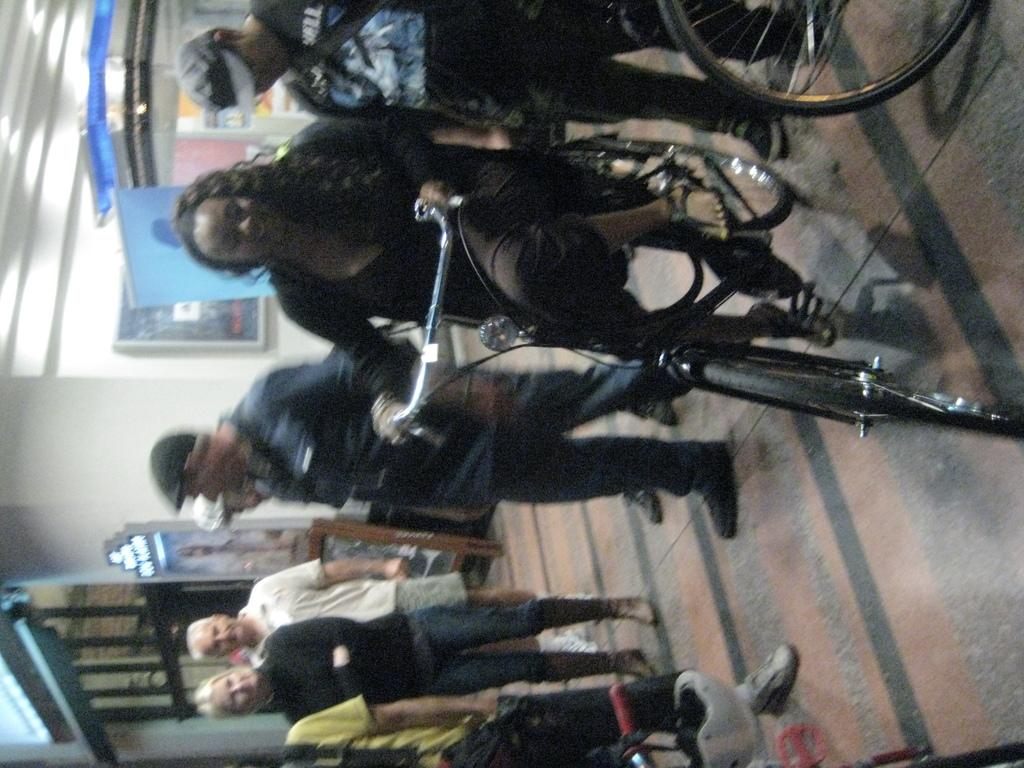What is happening with the group of people in the image? There is a group of people standing in the image. What is the person in front of the group doing? The person in front of the group is riding a bicycle. What can be seen in the background of the image? There are stalls visible in the background of the image. What color is the wall in the background? The wall in the background is white. How many pies are being sold at the stalls in the image? There is no information about pies being sold at the stalls in the image. Are the pigs in the image moving or standing still? There are no pigs present in the image. 